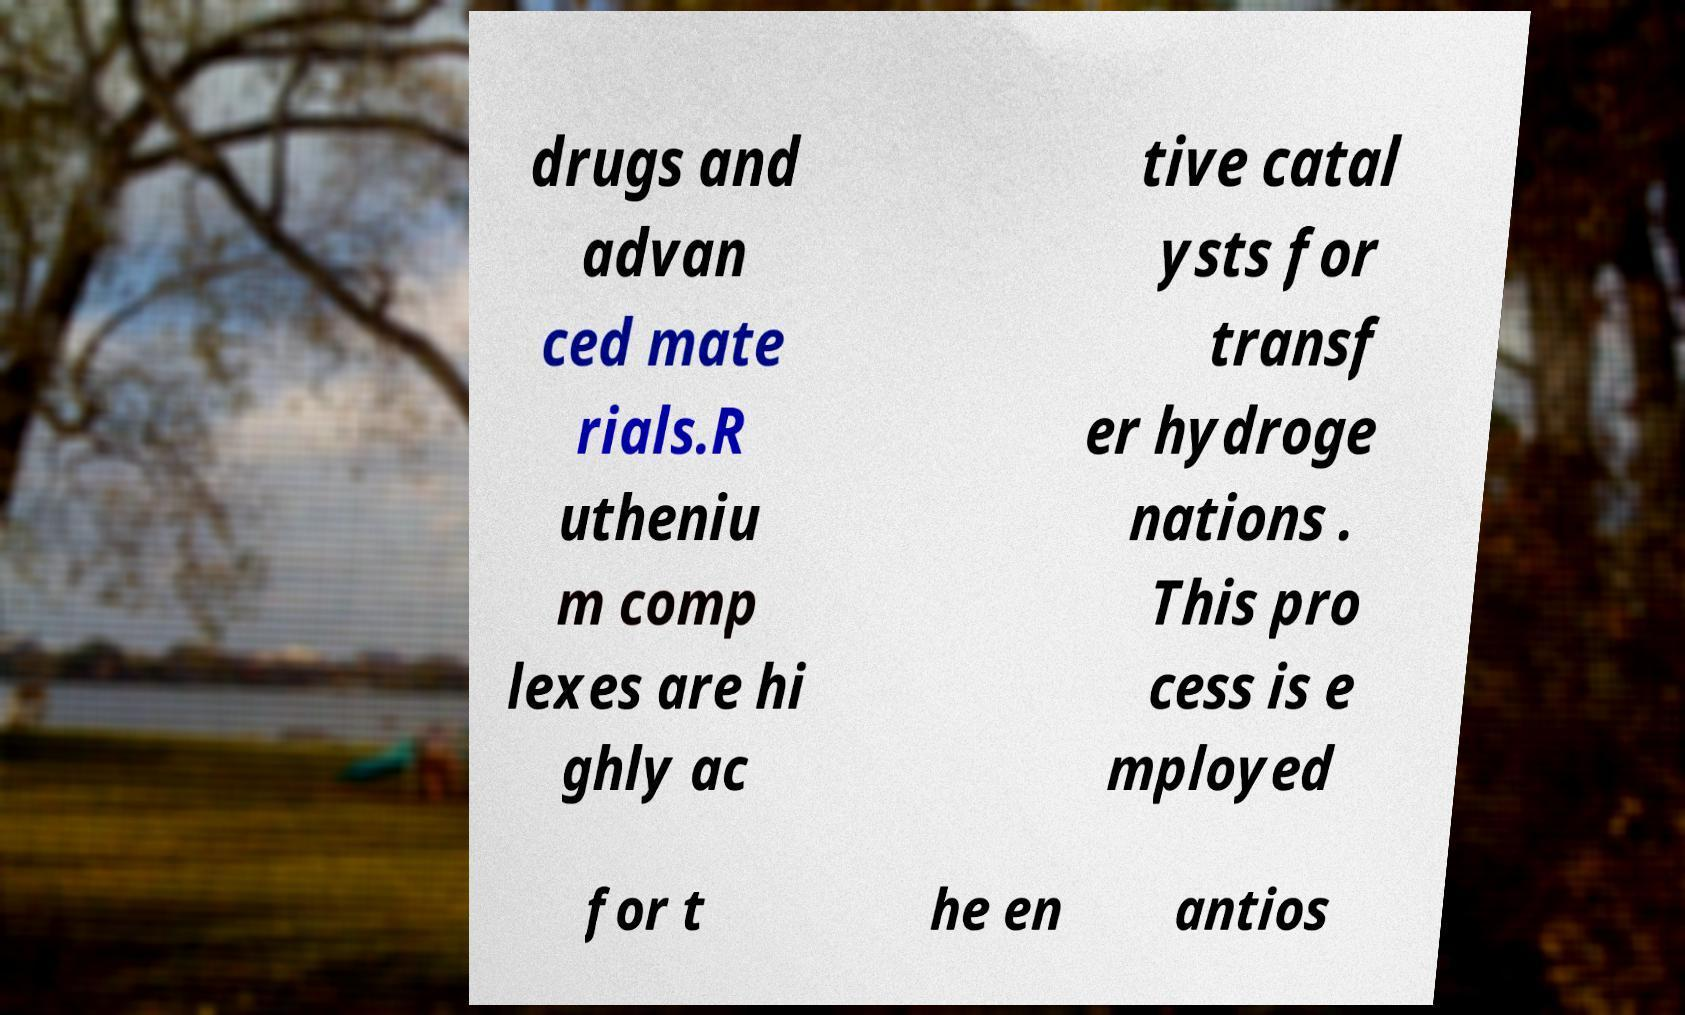Could you assist in decoding the text presented in this image and type it out clearly? drugs and advan ced mate rials.R utheniu m comp lexes are hi ghly ac tive catal ysts for transf er hydroge nations . This pro cess is e mployed for t he en antios 